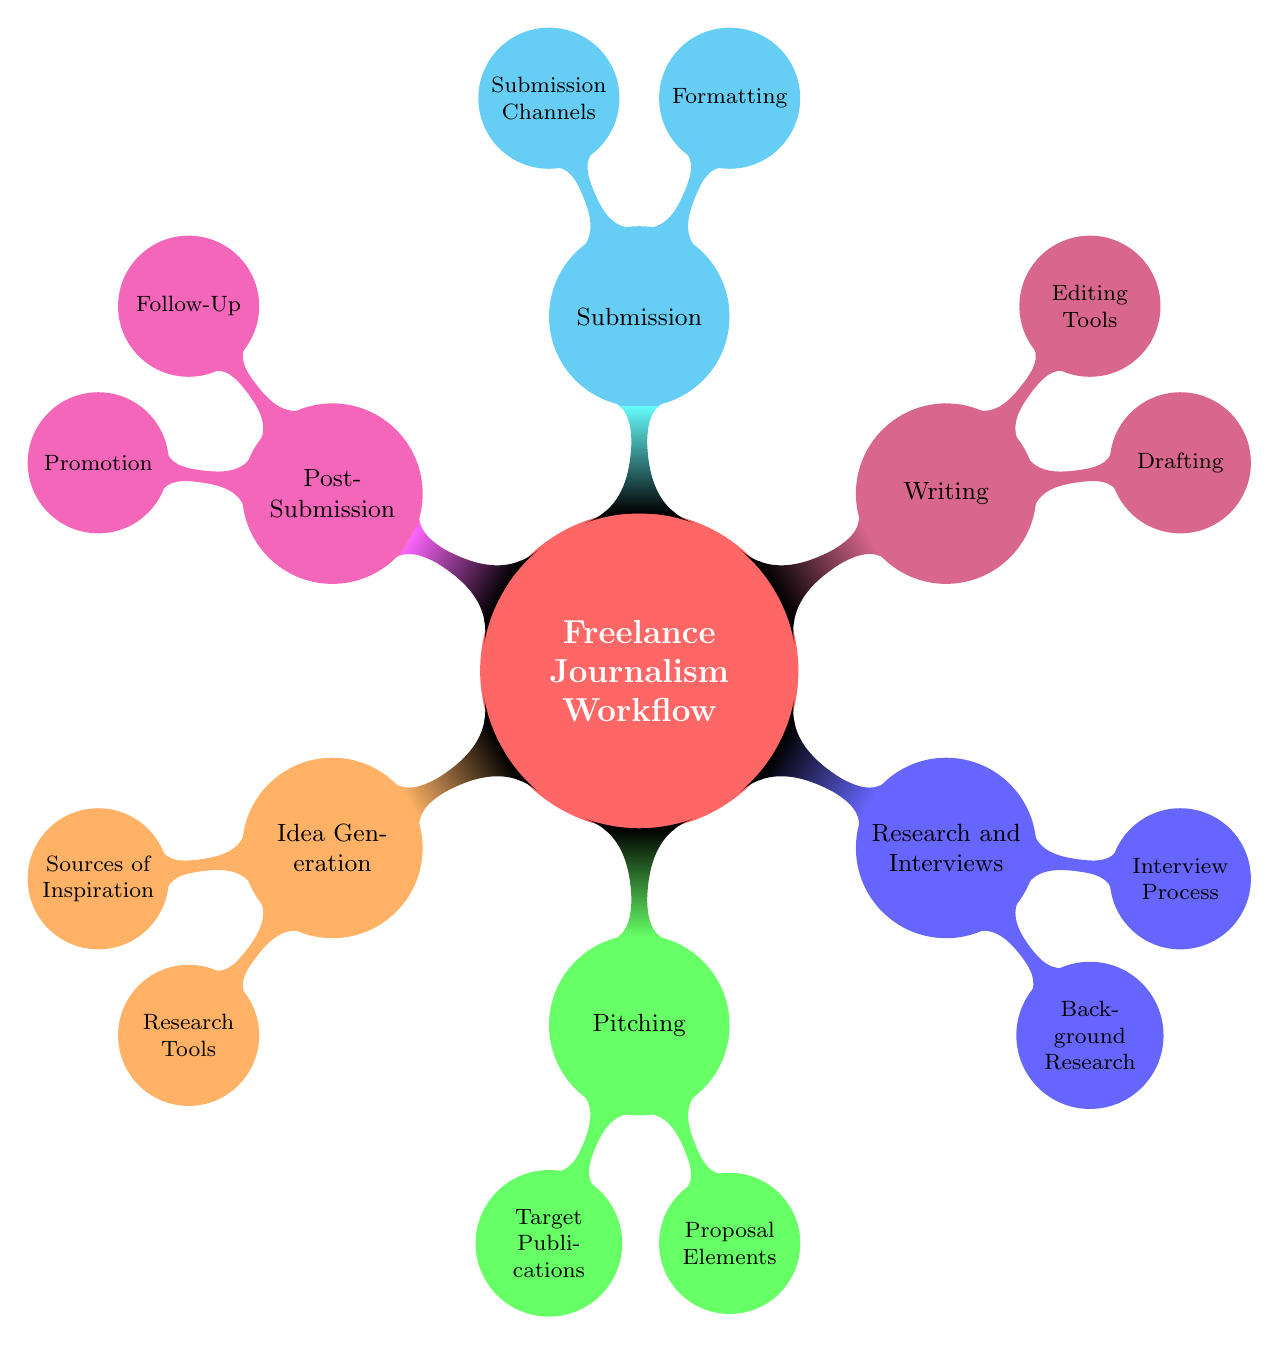What are the two main nodes under the "Freelance Journalism Workflow"? The main nodes are "Idea Generation" and "Pitching." These are the first layers in the mind map that branch out from the central concept.
Answer: Idea Generation, Pitching How many sources of inspiration are listed in the diagram? There are three sources of inspiration mentioned under "Idea Generation." They include current events, social media trends, and personal interests. Counting these elements gives a total of three.
Answer: 3 What element is common to both "Pitching" and "Post-Submission"? Both "Pitching" and "Post-Submission" include components related to the process of freelance journalism. "Pitching" contains proposal elements, while "Post-Submission" includes follow-up activities, showing a flow in the workflow from creating proposals to following up after submission.
Answer: Elements related to process Which node contains the most elements? The "Research and Interviews" node contains both the "Background Research" and "Interview Process" sub-nodes. Each of those has multiple components contributing to its larger content, making it more complex than other single nodes.
Answer: Research and Interviews List two submission channels mentioned in the diagram. The submission channels listed are email and online submission portals. These are specific routes through which freelance journalists can submit their work for consideration.
Answer: Email, Online Submission Portals How does the "Follow-Up" relate to the "Submission" node? "Follow-Up" is the first part of the "Post-Submission" node, which comes after "Submission." This indicates that follow-up actions occur after a submission is made, showing a progression in the workflow.
Answer: Post-Submission follows Submission What is the focus of the "Editing Tools" under the "Writing" node? The "Editing Tools" include tools such as Grammarly and Hemingway App. These tools focus on enhancing and refining the writing process to ensure clarity and grammatical correctness before final submission.
Answer: Grammarly, Hemingway App What are the two elements listed under "Proposal Elements" in the Pitching section? The two elements in the "Proposal Elements" are "Headline" and "Summary." These are critical components that are necessary to craft a compelling pitch for publications.
Answer: Headline, Summary 